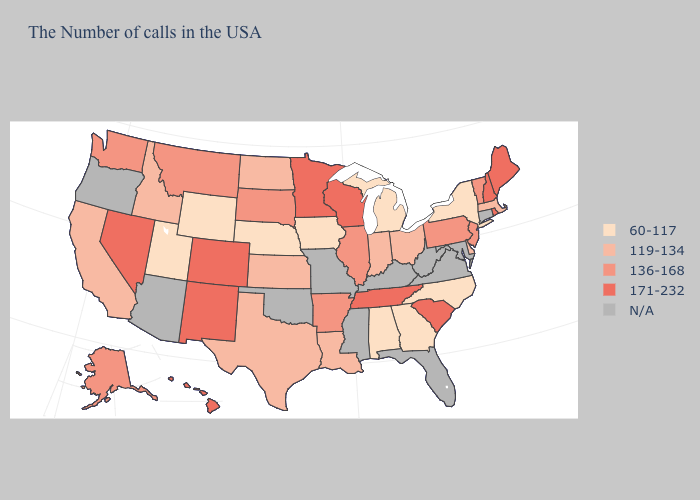Name the states that have a value in the range 136-168?
Quick response, please. Vermont, New Jersey, Pennsylvania, Illinois, Arkansas, South Dakota, Montana, Washington, Alaska. Name the states that have a value in the range 136-168?
Give a very brief answer. Vermont, New Jersey, Pennsylvania, Illinois, Arkansas, South Dakota, Montana, Washington, Alaska. What is the lowest value in the USA?
Be succinct. 60-117. Name the states that have a value in the range 171-232?
Answer briefly. Maine, Rhode Island, New Hampshire, South Carolina, Tennessee, Wisconsin, Minnesota, Colorado, New Mexico, Nevada, Hawaii. What is the lowest value in states that border Ohio?
Be succinct. 60-117. Name the states that have a value in the range 136-168?
Write a very short answer. Vermont, New Jersey, Pennsylvania, Illinois, Arkansas, South Dakota, Montana, Washington, Alaska. Name the states that have a value in the range 119-134?
Quick response, please. Massachusetts, Delaware, Ohio, Indiana, Louisiana, Kansas, Texas, North Dakota, Idaho, California. What is the value of Mississippi?
Short answer required. N/A. What is the highest value in the MidWest ?
Quick response, please. 171-232. Name the states that have a value in the range 171-232?
Keep it brief. Maine, Rhode Island, New Hampshire, South Carolina, Tennessee, Wisconsin, Minnesota, Colorado, New Mexico, Nevada, Hawaii. Does the map have missing data?
Give a very brief answer. Yes. Among the states that border Nebraska , does Iowa have the highest value?
Keep it brief. No. Among the states that border New Hampshire , does Maine have the highest value?
Be succinct. Yes. What is the value of North Carolina?
Answer briefly. 60-117. What is the highest value in the USA?
Short answer required. 171-232. 